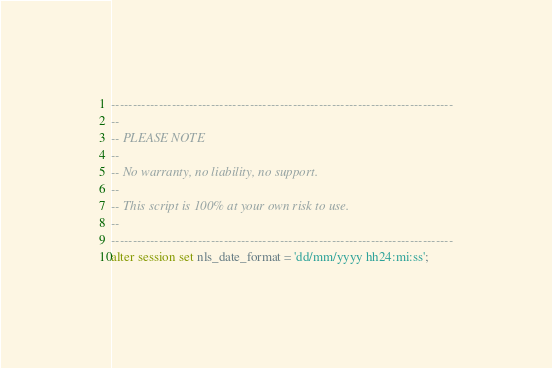<code> <loc_0><loc_0><loc_500><loc_500><_SQL_>-------------------------------------------------------------------------------
--
-- PLEASE NOTE
-- 
-- No warranty, no liability, no support.
--
-- This script is 100% at your own risk to use.
--
-------------------------------------------------------------------------------
alter session set nls_date_format = 'dd/mm/yyyy hh24:mi:ss';
</code> 